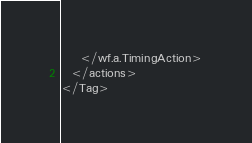<code> <loc_0><loc_0><loc_500><loc_500><_XML_>    </wf.a.TimingAction>
  </actions>
</Tag></code> 